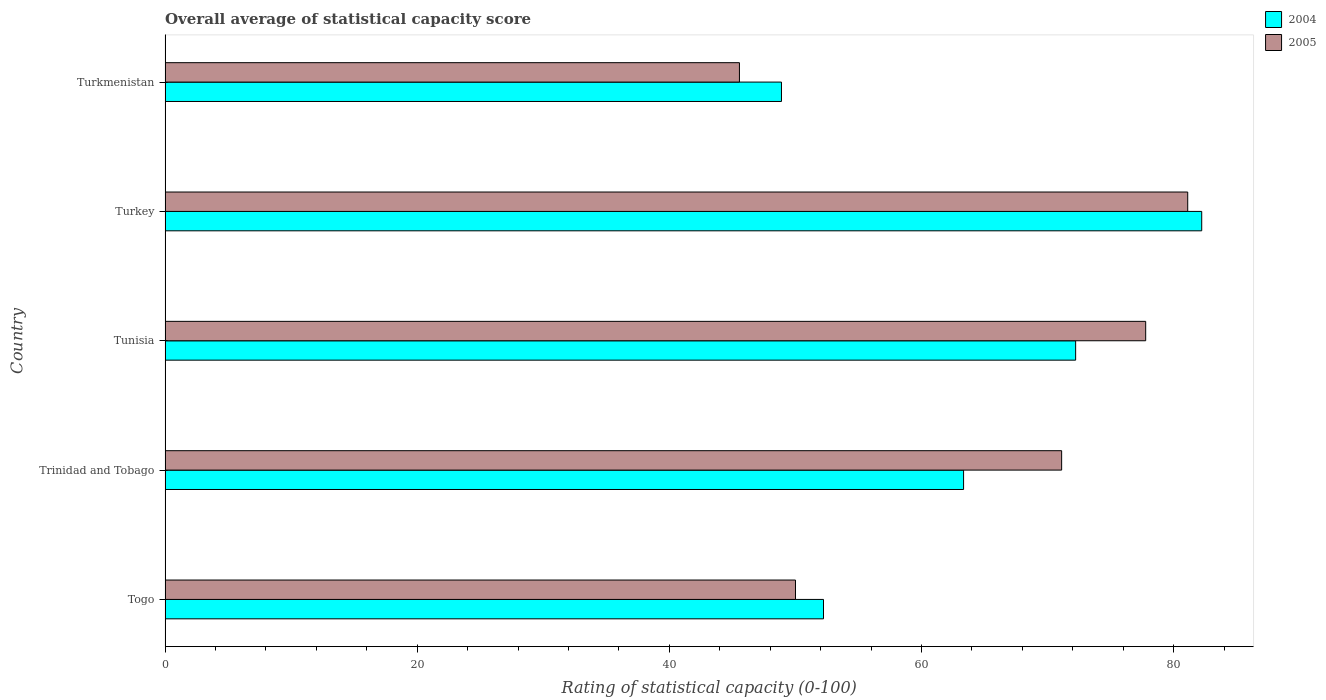What is the label of the 3rd group of bars from the top?
Make the answer very short. Tunisia. In how many cases, is the number of bars for a given country not equal to the number of legend labels?
Your answer should be compact. 0. What is the rating of statistical capacity in 2005 in Tunisia?
Your answer should be compact. 77.78. Across all countries, what is the maximum rating of statistical capacity in 2005?
Ensure brevity in your answer.  81.11. Across all countries, what is the minimum rating of statistical capacity in 2004?
Offer a very short reply. 48.89. In which country was the rating of statistical capacity in 2004 minimum?
Give a very brief answer. Turkmenistan. What is the total rating of statistical capacity in 2005 in the graph?
Your answer should be compact. 325.56. What is the difference between the rating of statistical capacity in 2004 in Trinidad and Tobago and that in Turkmenistan?
Your response must be concise. 14.44. What is the difference between the rating of statistical capacity in 2005 in Trinidad and Tobago and the rating of statistical capacity in 2004 in Tunisia?
Provide a succinct answer. -1.11. What is the average rating of statistical capacity in 2005 per country?
Provide a short and direct response. 65.11. What is the difference between the rating of statistical capacity in 2004 and rating of statistical capacity in 2005 in Togo?
Your answer should be compact. 2.22. In how many countries, is the rating of statistical capacity in 2005 greater than 32 ?
Your answer should be compact. 5. What is the ratio of the rating of statistical capacity in 2005 in Turkey to that in Turkmenistan?
Your answer should be very brief. 1.78. Is the difference between the rating of statistical capacity in 2004 in Togo and Turkey greater than the difference between the rating of statistical capacity in 2005 in Togo and Turkey?
Offer a terse response. Yes. What is the difference between the highest and the second highest rating of statistical capacity in 2005?
Offer a terse response. 3.33. What is the difference between the highest and the lowest rating of statistical capacity in 2005?
Your answer should be very brief. 35.56. Is the sum of the rating of statistical capacity in 2004 in Trinidad and Tobago and Tunisia greater than the maximum rating of statistical capacity in 2005 across all countries?
Provide a short and direct response. Yes. What does the 1st bar from the top in Tunisia represents?
Your response must be concise. 2005. How many countries are there in the graph?
Your answer should be compact. 5. What is the difference between two consecutive major ticks on the X-axis?
Offer a terse response. 20. Are the values on the major ticks of X-axis written in scientific E-notation?
Make the answer very short. No. How many legend labels are there?
Your response must be concise. 2. How are the legend labels stacked?
Your answer should be very brief. Vertical. What is the title of the graph?
Provide a succinct answer. Overall average of statistical capacity score. Does "1960" appear as one of the legend labels in the graph?
Offer a very short reply. No. What is the label or title of the X-axis?
Your answer should be very brief. Rating of statistical capacity (0-100). What is the label or title of the Y-axis?
Your response must be concise. Country. What is the Rating of statistical capacity (0-100) of 2004 in Togo?
Your response must be concise. 52.22. What is the Rating of statistical capacity (0-100) of 2004 in Trinidad and Tobago?
Your answer should be compact. 63.33. What is the Rating of statistical capacity (0-100) in 2005 in Trinidad and Tobago?
Give a very brief answer. 71.11. What is the Rating of statistical capacity (0-100) of 2004 in Tunisia?
Your answer should be compact. 72.22. What is the Rating of statistical capacity (0-100) in 2005 in Tunisia?
Make the answer very short. 77.78. What is the Rating of statistical capacity (0-100) in 2004 in Turkey?
Make the answer very short. 82.22. What is the Rating of statistical capacity (0-100) in 2005 in Turkey?
Provide a short and direct response. 81.11. What is the Rating of statistical capacity (0-100) in 2004 in Turkmenistan?
Your response must be concise. 48.89. What is the Rating of statistical capacity (0-100) of 2005 in Turkmenistan?
Your response must be concise. 45.56. Across all countries, what is the maximum Rating of statistical capacity (0-100) of 2004?
Ensure brevity in your answer.  82.22. Across all countries, what is the maximum Rating of statistical capacity (0-100) of 2005?
Offer a terse response. 81.11. Across all countries, what is the minimum Rating of statistical capacity (0-100) in 2004?
Make the answer very short. 48.89. Across all countries, what is the minimum Rating of statistical capacity (0-100) of 2005?
Keep it short and to the point. 45.56. What is the total Rating of statistical capacity (0-100) of 2004 in the graph?
Give a very brief answer. 318.89. What is the total Rating of statistical capacity (0-100) of 2005 in the graph?
Your response must be concise. 325.56. What is the difference between the Rating of statistical capacity (0-100) in 2004 in Togo and that in Trinidad and Tobago?
Provide a succinct answer. -11.11. What is the difference between the Rating of statistical capacity (0-100) of 2005 in Togo and that in Trinidad and Tobago?
Your response must be concise. -21.11. What is the difference between the Rating of statistical capacity (0-100) of 2004 in Togo and that in Tunisia?
Offer a terse response. -20. What is the difference between the Rating of statistical capacity (0-100) of 2005 in Togo and that in Tunisia?
Your answer should be compact. -27.78. What is the difference between the Rating of statistical capacity (0-100) in 2004 in Togo and that in Turkey?
Your response must be concise. -30. What is the difference between the Rating of statistical capacity (0-100) in 2005 in Togo and that in Turkey?
Keep it short and to the point. -31.11. What is the difference between the Rating of statistical capacity (0-100) in 2005 in Togo and that in Turkmenistan?
Give a very brief answer. 4.44. What is the difference between the Rating of statistical capacity (0-100) in 2004 in Trinidad and Tobago and that in Tunisia?
Ensure brevity in your answer.  -8.89. What is the difference between the Rating of statistical capacity (0-100) of 2005 in Trinidad and Tobago and that in Tunisia?
Make the answer very short. -6.67. What is the difference between the Rating of statistical capacity (0-100) of 2004 in Trinidad and Tobago and that in Turkey?
Offer a terse response. -18.89. What is the difference between the Rating of statistical capacity (0-100) of 2004 in Trinidad and Tobago and that in Turkmenistan?
Provide a short and direct response. 14.44. What is the difference between the Rating of statistical capacity (0-100) of 2005 in Trinidad and Tobago and that in Turkmenistan?
Provide a short and direct response. 25.56. What is the difference between the Rating of statistical capacity (0-100) of 2004 in Tunisia and that in Turkmenistan?
Your answer should be compact. 23.33. What is the difference between the Rating of statistical capacity (0-100) of 2005 in Tunisia and that in Turkmenistan?
Your answer should be very brief. 32.22. What is the difference between the Rating of statistical capacity (0-100) in 2004 in Turkey and that in Turkmenistan?
Your answer should be very brief. 33.33. What is the difference between the Rating of statistical capacity (0-100) in 2005 in Turkey and that in Turkmenistan?
Provide a succinct answer. 35.56. What is the difference between the Rating of statistical capacity (0-100) in 2004 in Togo and the Rating of statistical capacity (0-100) in 2005 in Trinidad and Tobago?
Your answer should be compact. -18.89. What is the difference between the Rating of statistical capacity (0-100) in 2004 in Togo and the Rating of statistical capacity (0-100) in 2005 in Tunisia?
Offer a terse response. -25.56. What is the difference between the Rating of statistical capacity (0-100) in 2004 in Togo and the Rating of statistical capacity (0-100) in 2005 in Turkey?
Make the answer very short. -28.89. What is the difference between the Rating of statistical capacity (0-100) in 2004 in Trinidad and Tobago and the Rating of statistical capacity (0-100) in 2005 in Tunisia?
Give a very brief answer. -14.44. What is the difference between the Rating of statistical capacity (0-100) in 2004 in Trinidad and Tobago and the Rating of statistical capacity (0-100) in 2005 in Turkey?
Your answer should be very brief. -17.78. What is the difference between the Rating of statistical capacity (0-100) in 2004 in Trinidad and Tobago and the Rating of statistical capacity (0-100) in 2005 in Turkmenistan?
Your answer should be very brief. 17.78. What is the difference between the Rating of statistical capacity (0-100) in 2004 in Tunisia and the Rating of statistical capacity (0-100) in 2005 in Turkey?
Make the answer very short. -8.89. What is the difference between the Rating of statistical capacity (0-100) in 2004 in Tunisia and the Rating of statistical capacity (0-100) in 2005 in Turkmenistan?
Provide a succinct answer. 26.67. What is the difference between the Rating of statistical capacity (0-100) in 2004 in Turkey and the Rating of statistical capacity (0-100) in 2005 in Turkmenistan?
Provide a short and direct response. 36.67. What is the average Rating of statistical capacity (0-100) of 2004 per country?
Provide a succinct answer. 63.78. What is the average Rating of statistical capacity (0-100) in 2005 per country?
Offer a very short reply. 65.11. What is the difference between the Rating of statistical capacity (0-100) of 2004 and Rating of statistical capacity (0-100) of 2005 in Togo?
Offer a terse response. 2.22. What is the difference between the Rating of statistical capacity (0-100) in 2004 and Rating of statistical capacity (0-100) in 2005 in Trinidad and Tobago?
Give a very brief answer. -7.78. What is the difference between the Rating of statistical capacity (0-100) of 2004 and Rating of statistical capacity (0-100) of 2005 in Tunisia?
Keep it short and to the point. -5.56. What is the difference between the Rating of statistical capacity (0-100) of 2004 and Rating of statistical capacity (0-100) of 2005 in Turkey?
Make the answer very short. 1.11. What is the difference between the Rating of statistical capacity (0-100) of 2004 and Rating of statistical capacity (0-100) of 2005 in Turkmenistan?
Your response must be concise. 3.33. What is the ratio of the Rating of statistical capacity (0-100) of 2004 in Togo to that in Trinidad and Tobago?
Give a very brief answer. 0.82. What is the ratio of the Rating of statistical capacity (0-100) of 2005 in Togo to that in Trinidad and Tobago?
Your answer should be very brief. 0.7. What is the ratio of the Rating of statistical capacity (0-100) in 2004 in Togo to that in Tunisia?
Provide a succinct answer. 0.72. What is the ratio of the Rating of statistical capacity (0-100) in 2005 in Togo to that in Tunisia?
Give a very brief answer. 0.64. What is the ratio of the Rating of statistical capacity (0-100) of 2004 in Togo to that in Turkey?
Give a very brief answer. 0.64. What is the ratio of the Rating of statistical capacity (0-100) of 2005 in Togo to that in Turkey?
Offer a terse response. 0.62. What is the ratio of the Rating of statistical capacity (0-100) of 2004 in Togo to that in Turkmenistan?
Give a very brief answer. 1.07. What is the ratio of the Rating of statistical capacity (0-100) of 2005 in Togo to that in Turkmenistan?
Make the answer very short. 1.1. What is the ratio of the Rating of statistical capacity (0-100) in 2004 in Trinidad and Tobago to that in Tunisia?
Make the answer very short. 0.88. What is the ratio of the Rating of statistical capacity (0-100) in 2005 in Trinidad and Tobago to that in Tunisia?
Provide a short and direct response. 0.91. What is the ratio of the Rating of statistical capacity (0-100) of 2004 in Trinidad and Tobago to that in Turkey?
Your response must be concise. 0.77. What is the ratio of the Rating of statistical capacity (0-100) of 2005 in Trinidad and Tobago to that in Turkey?
Your answer should be compact. 0.88. What is the ratio of the Rating of statistical capacity (0-100) of 2004 in Trinidad and Tobago to that in Turkmenistan?
Give a very brief answer. 1.3. What is the ratio of the Rating of statistical capacity (0-100) of 2005 in Trinidad and Tobago to that in Turkmenistan?
Provide a short and direct response. 1.56. What is the ratio of the Rating of statistical capacity (0-100) of 2004 in Tunisia to that in Turkey?
Keep it short and to the point. 0.88. What is the ratio of the Rating of statistical capacity (0-100) in 2005 in Tunisia to that in Turkey?
Offer a terse response. 0.96. What is the ratio of the Rating of statistical capacity (0-100) in 2004 in Tunisia to that in Turkmenistan?
Your answer should be compact. 1.48. What is the ratio of the Rating of statistical capacity (0-100) in 2005 in Tunisia to that in Turkmenistan?
Provide a short and direct response. 1.71. What is the ratio of the Rating of statistical capacity (0-100) of 2004 in Turkey to that in Turkmenistan?
Provide a succinct answer. 1.68. What is the ratio of the Rating of statistical capacity (0-100) of 2005 in Turkey to that in Turkmenistan?
Provide a short and direct response. 1.78. What is the difference between the highest and the second highest Rating of statistical capacity (0-100) in 2005?
Provide a short and direct response. 3.33. What is the difference between the highest and the lowest Rating of statistical capacity (0-100) of 2004?
Ensure brevity in your answer.  33.33. What is the difference between the highest and the lowest Rating of statistical capacity (0-100) of 2005?
Offer a very short reply. 35.56. 